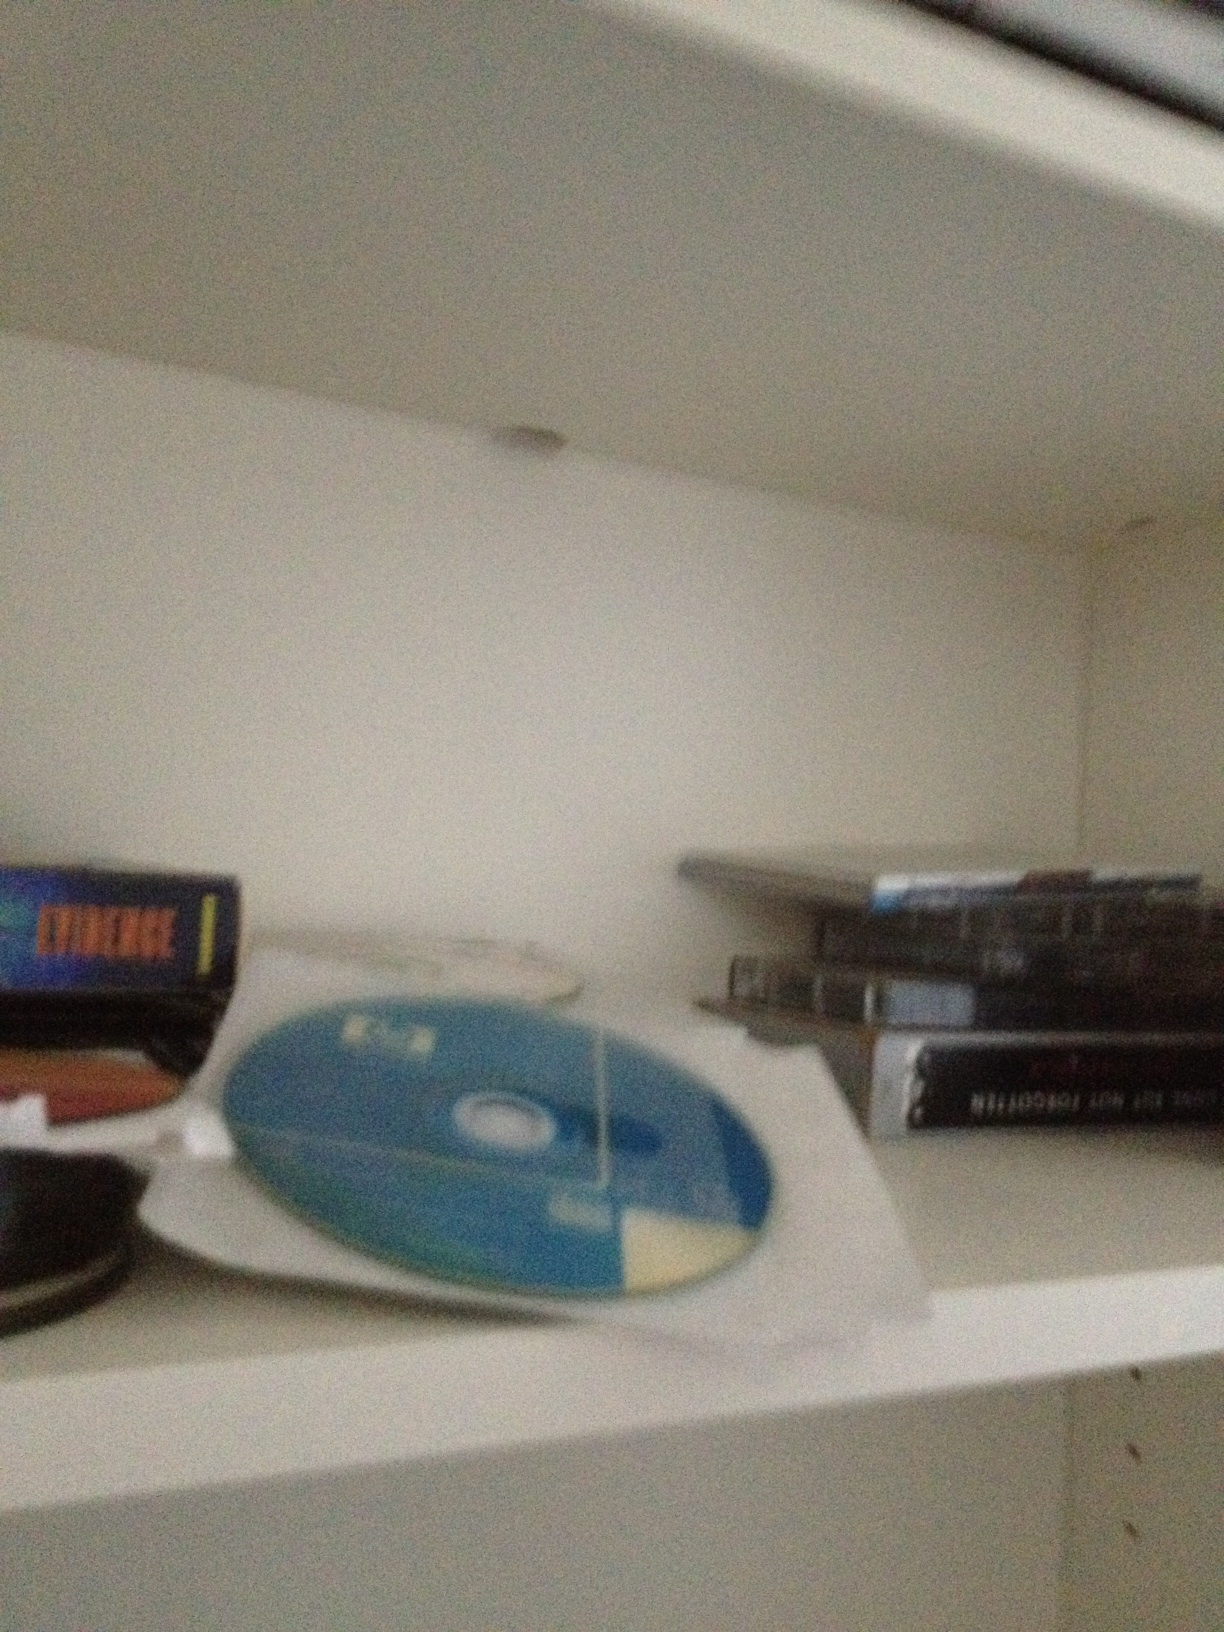Pretend this shelf is in an alien spacecraft. What do the discs represent? On an alien spacecraft, these discs could represent ancient artifacts from various civilizations across the universe. Each disc contains a wealth of knowledge, music, and history from different worlds, cataloged and preserved by the aliens in their quest to understand the cultures of the cosmos. This shelf is part of their grand library, a testament to their dedication to learning and preserving the heritage of countless species. 